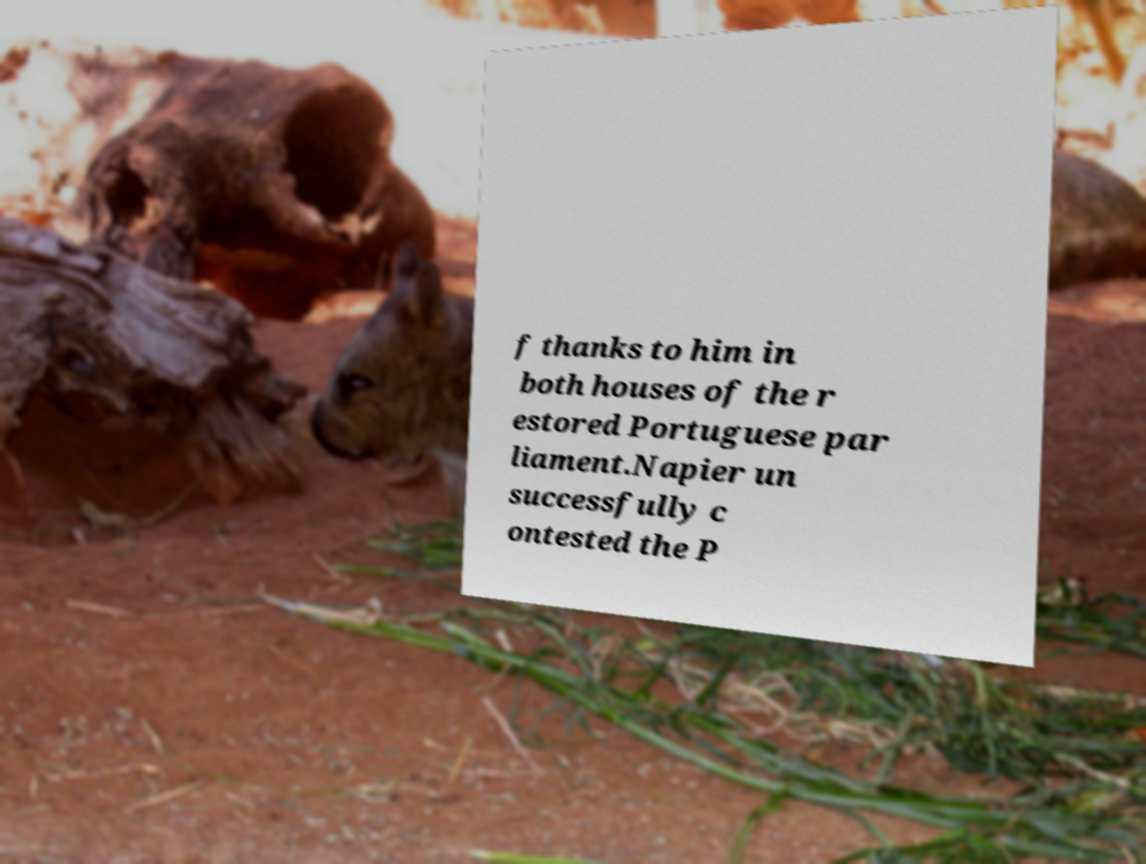I need the written content from this picture converted into text. Can you do that? f thanks to him in both houses of the r estored Portuguese par liament.Napier un successfully c ontested the P 